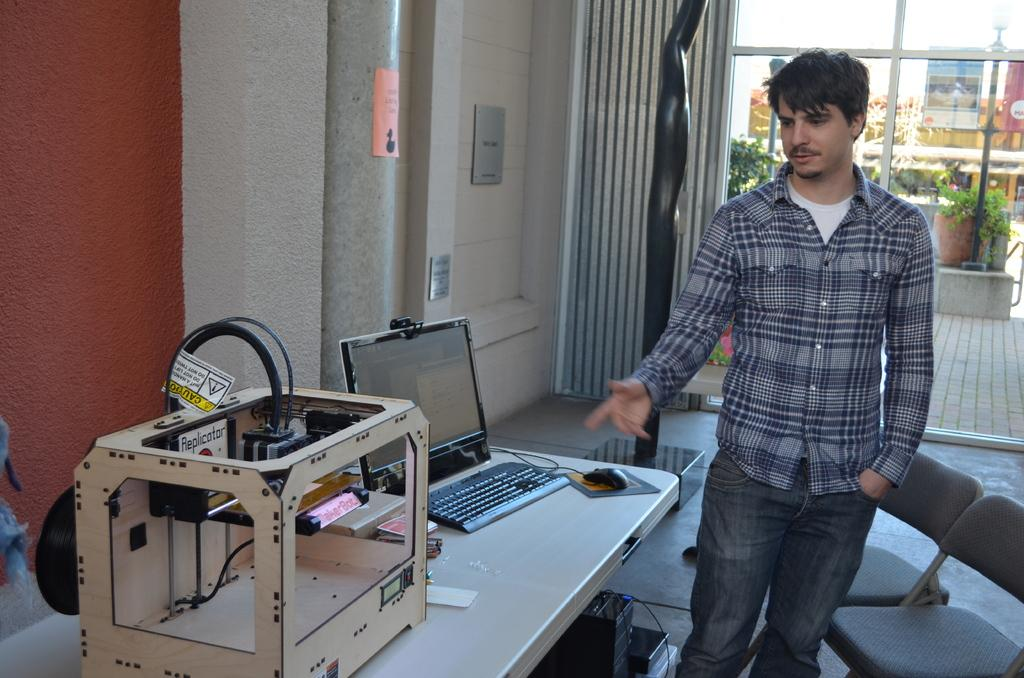What is the man in the image doing? The man is standing in the image. What piece of furniture is present in the image? There is a chair in the image. What electronic devices can be seen in the image? There is a laptop, a keyboard, and a mouse in the image. What object is on the table in the image? There is a device on the table in the image. What can be seen in the background of the image? There is a building and a flower pot in the background of the image. What type of poison is being used to decorate the cakes in the image? There are no cakes present in the image, so it is not possible to determine if any poison is being used to decorate them. 